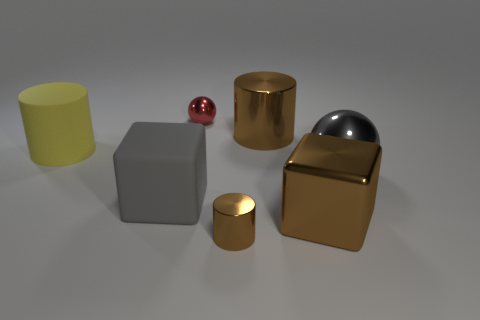The small brown thing has what shape? The small brown object in the image is cylindrical in shape. It resembles a common cylinder with smooth, curved surfaces and flat circular ends, positioned between other geometric shapes on the left side of the image. 